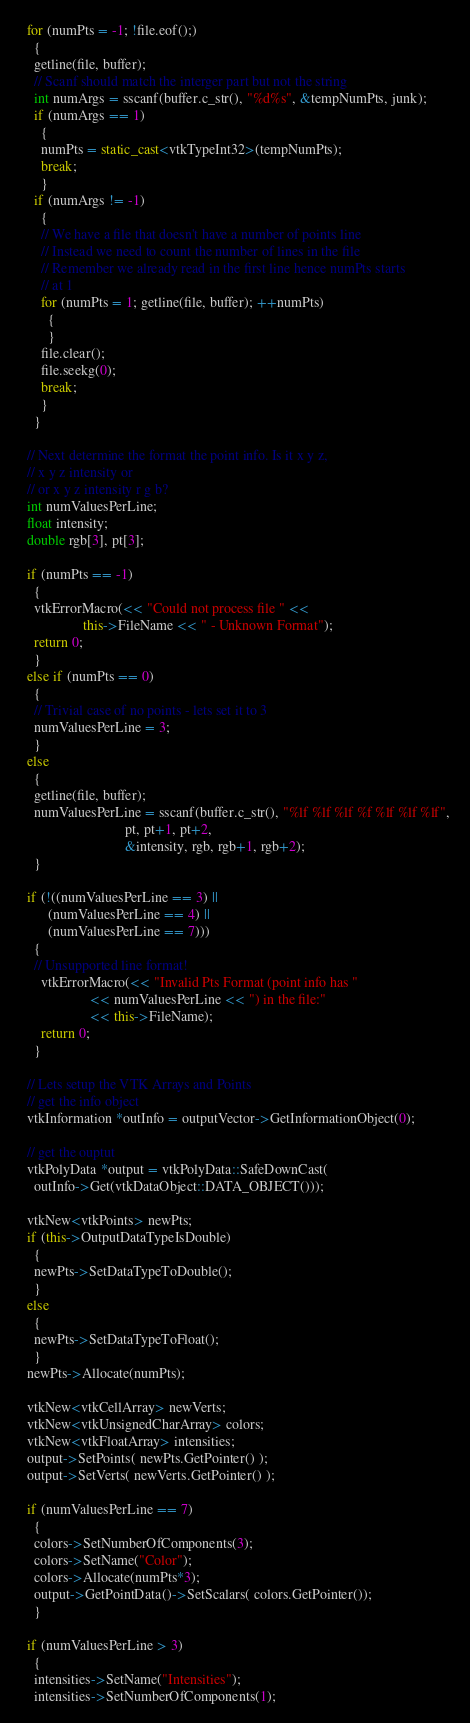<code> <loc_0><loc_0><loc_500><loc_500><_C++_>  for (numPts = -1; !file.eof();)
    {
    getline(file, buffer);
    // Scanf should match the interger part but not the string
    int numArgs = sscanf(buffer.c_str(), "%d%s", &tempNumPts, junk);
    if (numArgs == 1)
      {
      numPts = static_cast<vtkTypeInt32>(tempNumPts);
      break;
      }
    if (numArgs != -1)
      {
      // We have a file that doesn't have a number of points line
      // Instead we need to count the number of lines in the file
      // Remember we already read in the first line hence numPts starts
      // at 1
      for (numPts = 1; getline(file, buffer); ++numPts)
        {
        }
      file.clear();
      file.seekg(0);
      break;
      }
    }

  // Next determine the format the point info. Is it x y z,
  // x y z intensity or
  // or x y z intensity r g b?
  int numValuesPerLine;
  float intensity;
  double rgb[3], pt[3];

  if (numPts == -1)
    {
    vtkErrorMacro(<< "Could not process file " <<
                  this->FileName << " - Unknown Format");
    return 0;
    }
  else if (numPts == 0)
    {
    // Trivial case of no points - lets set it to 3
    numValuesPerLine = 3;
    }
  else
    {
    getline(file, buffer);
    numValuesPerLine = sscanf(buffer.c_str(), "%lf %lf %lf %f %lf %lf %lf",
                              pt, pt+1, pt+2,
                              &intensity, rgb, rgb+1, rgb+2);
    }

  if (!((numValuesPerLine == 3) ||
        (numValuesPerLine == 4) ||
        (numValuesPerLine == 7)))
    {
    // Unsupported line format!
      vtkErrorMacro(<< "Invalid Pts Format (point info has "
                    << numValuesPerLine << ") in the file:"
                    << this->FileName);
      return 0;
    }

  // Lets setup the VTK Arrays and Points
  // get the info object
  vtkInformation *outInfo = outputVector->GetInformationObject(0);

  // get the ouptut
  vtkPolyData *output = vtkPolyData::SafeDownCast(
    outInfo->Get(vtkDataObject::DATA_OBJECT()));

  vtkNew<vtkPoints> newPts;
  if (this->OutputDataTypeIsDouble)
    {
    newPts->SetDataTypeToDouble();
    }
  else
    {
    newPts->SetDataTypeToFloat();
    }
  newPts->Allocate(numPts);

  vtkNew<vtkCellArray> newVerts;
  vtkNew<vtkUnsignedCharArray> colors;
  vtkNew<vtkFloatArray> intensities;
  output->SetPoints( newPts.GetPointer() );
  output->SetVerts( newVerts.GetPointer() );

  if (numValuesPerLine == 7)
    {
    colors->SetNumberOfComponents(3);
    colors->SetName("Color");
    colors->Allocate(numPts*3);
    output->GetPointData()->SetScalars( colors.GetPointer());
    }

  if (numValuesPerLine > 3)
    {
    intensities->SetName("Intensities");
    intensities->SetNumberOfComponents(1);</code> 